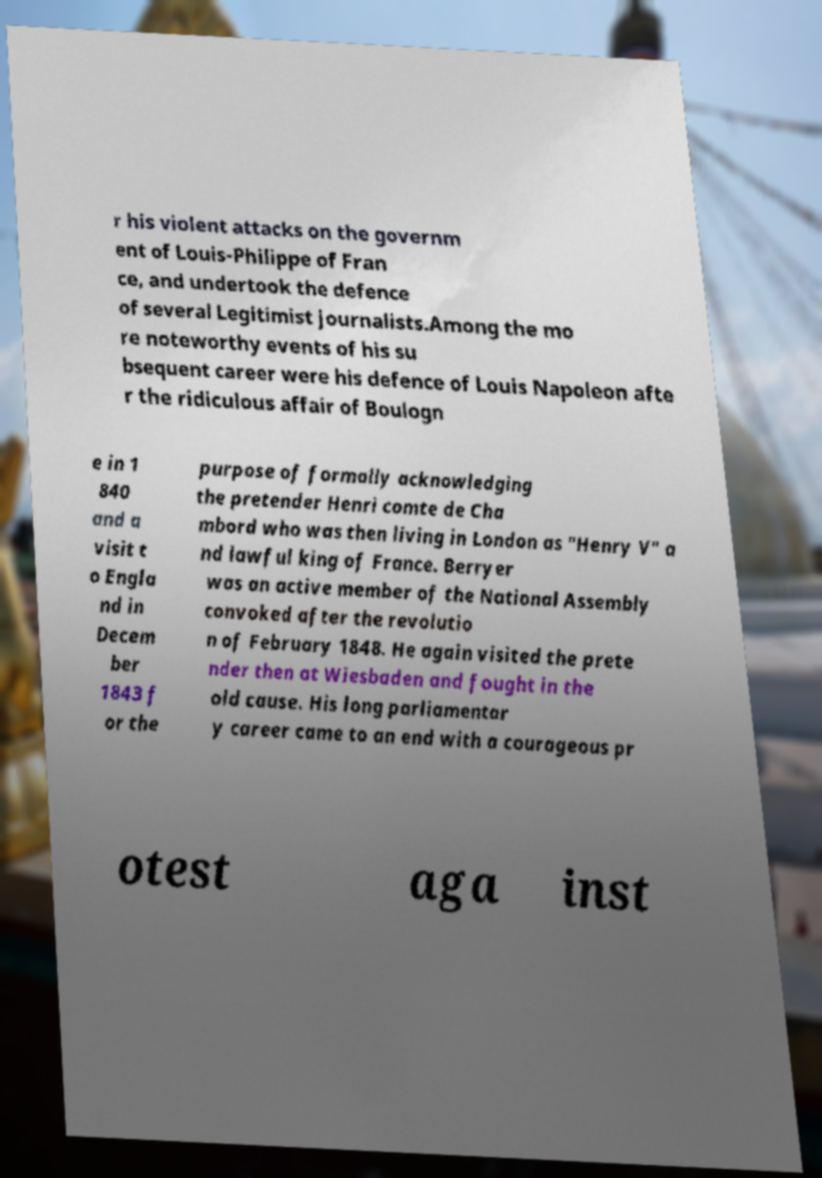What messages or text are displayed in this image? I need them in a readable, typed format. r his violent attacks on the governm ent of Louis-Philippe of Fran ce, and undertook the defence of several Legitimist journalists.Among the mo re noteworthy events of his su bsequent career were his defence of Louis Napoleon afte r the ridiculous affair of Boulogn e in 1 840 and a visit t o Engla nd in Decem ber 1843 f or the purpose of formally acknowledging the pretender Henri comte de Cha mbord who was then living in London as "Henry V" a nd lawful king of France. Berryer was an active member of the National Assembly convoked after the revolutio n of February 1848. He again visited the prete nder then at Wiesbaden and fought in the old cause. His long parliamentar y career came to an end with a courageous pr otest aga inst 